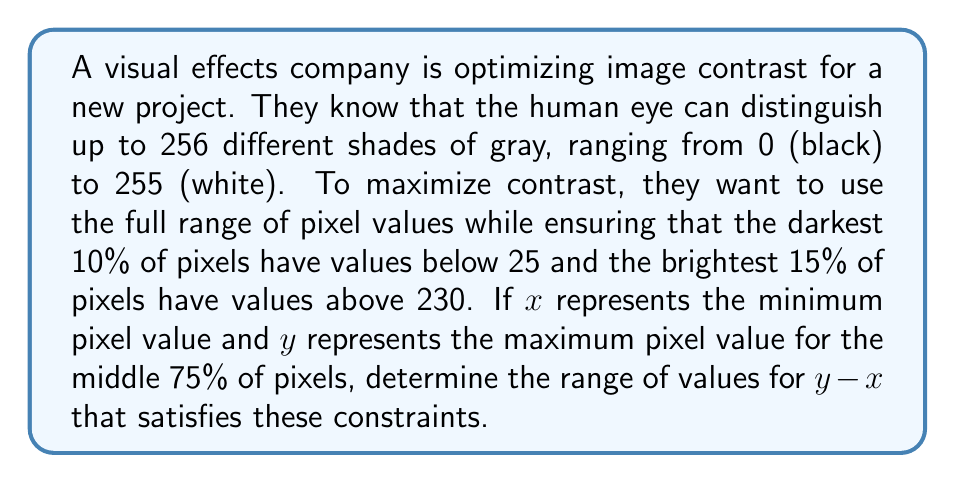What is the answer to this math problem? Let's approach this step-by-step:

1) First, we need to set up our inequalities based on the given information:

   $0 \leq x < 25$ (darkest 10% of pixels)
   $230 < y \leq 255$ (brightest 15% of pixels)

2) Now, we need to consider the middle 75% of pixels. These should fall between $x$ and $y$.

3) To maximize contrast, we want to maximize $y - x$ while satisfying these constraints.

4) The lower bound for $y - x$:
   - The minimum possible value for $y$ is just above 230, let's call it 231.
   - The maximum possible value for $x$ is just below 25, let's call it 24.
   - So, the minimum value for $y - x$ is:
     $$(y - x)_{min} = 231 - 24 = 207$$

5) The upper bound for $y - x$:
   - The maximum possible value for $y$ is 255.
   - The minimum possible value for $x$ is 0.
   - So, the maximum value for $y - x$ is:
     $$(y - x)_{max} = 255 - 0 = 255$$

6) Therefore, the range of values for $y - x$ that satisfies the constraints is:

   $$207 \leq y - x \leq 255$$
Answer: The range of values for $y - x$ that satisfies the constraints is $[207, 255]$, or mathematically expressed as:

$$207 \leq y - x \leq 255$$ 